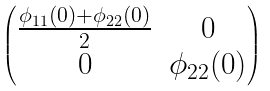<formula> <loc_0><loc_0><loc_500><loc_500>\begin{pmatrix} \frac { \phi _ { 1 1 } ( 0 ) + \phi _ { 2 2 } ( 0 ) } 2 & 0 \\ 0 & \phi _ { 2 2 } ( 0 ) \end{pmatrix}</formula> 